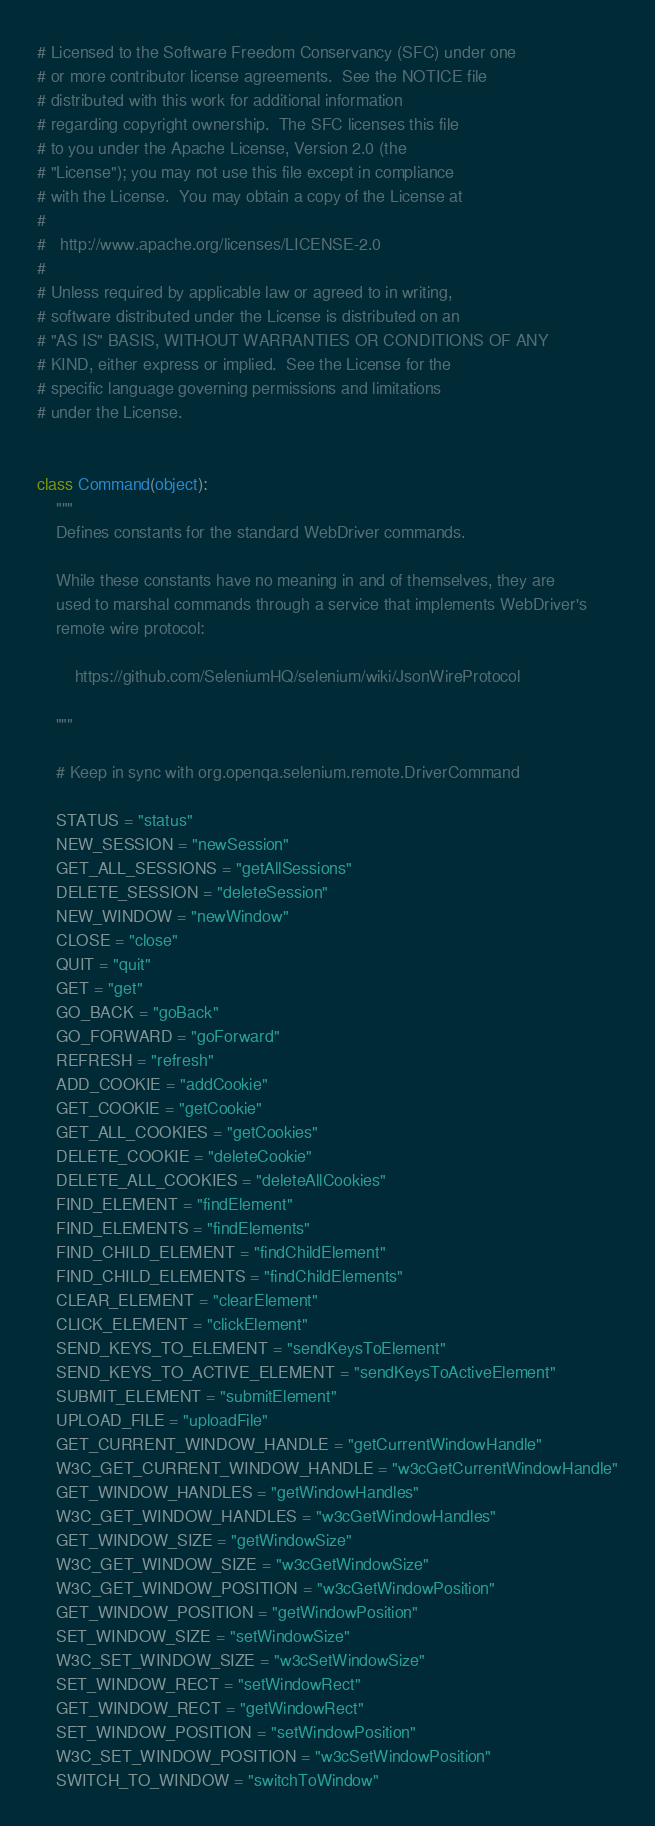<code> <loc_0><loc_0><loc_500><loc_500><_Python_># Licensed to the Software Freedom Conservancy (SFC) under one
# or more contributor license agreements.  See the NOTICE file
# distributed with this work for additional information
# regarding copyright ownership.  The SFC licenses this file
# to you under the Apache License, Version 2.0 (the
# "License"); you may not use this file except in compliance
# with the License.  You may obtain a copy of the License at
#
#   http://www.apache.org/licenses/LICENSE-2.0
#
# Unless required by applicable law or agreed to in writing,
# software distributed under the License is distributed on an
# "AS IS" BASIS, WITHOUT WARRANTIES OR CONDITIONS OF ANY
# KIND, either express or implied.  See the License for the
# specific language governing permissions and limitations
# under the License.


class Command(object):
    """
    Defines constants for the standard WebDriver commands.

    While these constants have no meaning in and of themselves, they are
    used to marshal commands through a service that implements WebDriver's
    remote wire protocol:

        https://github.com/SeleniumHQ/selenium/wiki/JsonWireProtocol

    """

    # Keep in sync with org.openqa.selenium.remote.DriverCommand

    STATUS = "status"
    NEW_SESSION = "newSession"
    GET_ALL_SESSIONS = "getAllSessions"
    DELETE_SESSION = "deleteSession"
    NEW_WINDOW = "newWindow"
    CLOSE = "close"
    QUIT = "quit"
    GET = "get"
    GO_BACK = "goBack"
    GO_FORWARD = "goForward"
    REFRESH = "refresh"
    ADD_COOKIE = "addCookie"
    GET_COOKIE = "getCookie"
    GET_ALL_COOKIES = "getCookies"
    DELETE_COOKIE = "deleteCookie"
    DELETE_ALL_COOKIES = "deleteAllCookies"
    FIND_ELEMENT = "findElement"
    FIND_ELEMENTS = "findElements"
    FIND_CHILD_ELEMENT = "findChildElement"
    FIND_CHILD_ELEMENTS = "findChildElements"
    CLEAR_ELEMENT = "clearElement"
    CLICK_ELEMENT = "clickElement"
    SEND_KEYS_TO_ELEMENT = "sendKeysToElement"
    SEND_KEYS_TO_ACTIVE_ELEMENT = "sendKeysToActiveElement"
    SUBMIT_ELEMENT = "submitElement"
    UPLOAD_FILE = "uploadFile"
    GET_CURRENT_WINDOW_HANDLE = "getCurrentWindowHandle"
    W3C_GET_CURRENT_WINDOW_HANDLE = "w3cGetCurrentWindowHandle"
    GET_WINDOW_HANDLES = "getWindowHandles"
    W3C_GET_WINDOW_HANDLES = "w3cGetWindowHandles"
    GET_WINDOW_SIZE = "getWindowSize"
    W3C_GET_WINDOW_SIZE = "w3cGetWindowSize"
    W3C_GET_WINDOW_POSITION = "w3cGetWindowPosition"
    GET_WINDOW_POSITION = "getWindowPosition"
    SET_WINDOW_SIZE = "setWindowSize"
    W3C_SET_WINDOW_SIZE = "w3cSetWindowSize"
    SET_WINDOW_RECT = "setWindowRect"
    GET_WINDOW_RECT = "getWindowRect"
    SET_WINDOW_POSITION = "setWindowPosition"
    W3C_SET_WINDOW_POSITION = "w3cSetWindowPosition"
    SWITCH_TO_WINDOW = "switchToWindow"</code> 